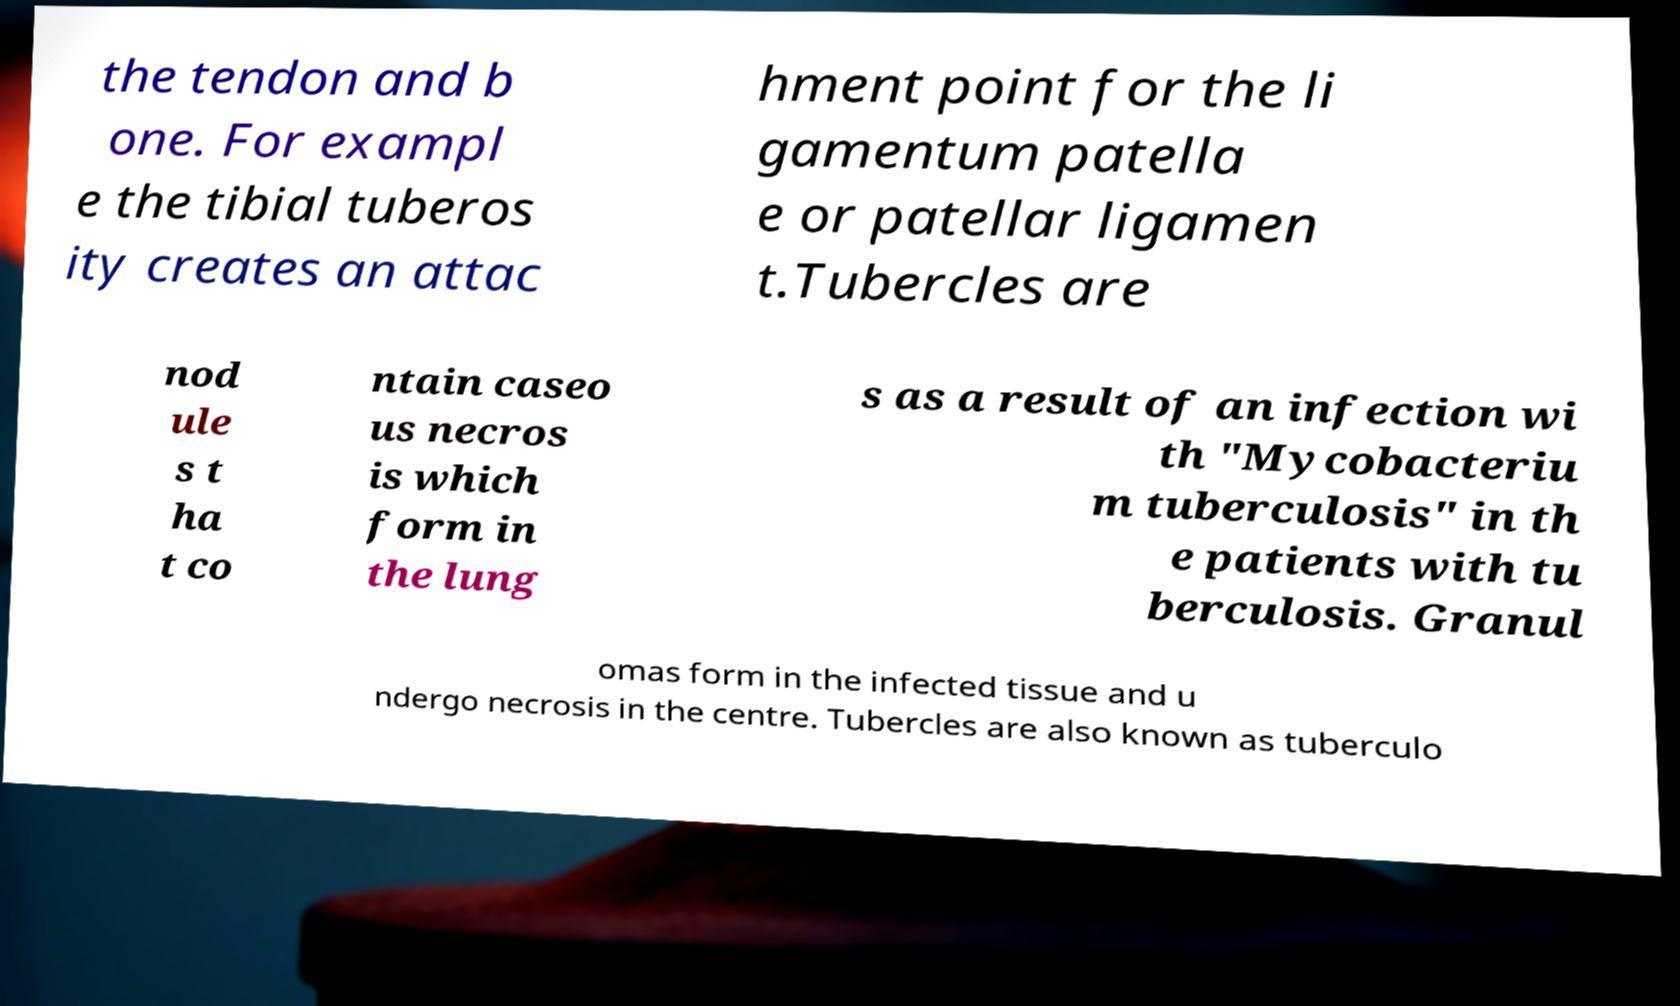For documentation purposes, I need the text within this image transcribed. Could you provide that? the tendon and b one. For exampl e the tibial tuberos ity creates an attac hment point for the li gamentum patella e or patellar ligamen t.Tubercles are nod ule s t ha t co ntain caseo us necros is which form in the lung s as a result of an infection wi th "Mycobacteriu m tuberculosis" in th e patients with tu berculosis. Granul omas form in the infected tissue and u ndergo necrosis in the centre. Tubercles are also known as tuberculo 